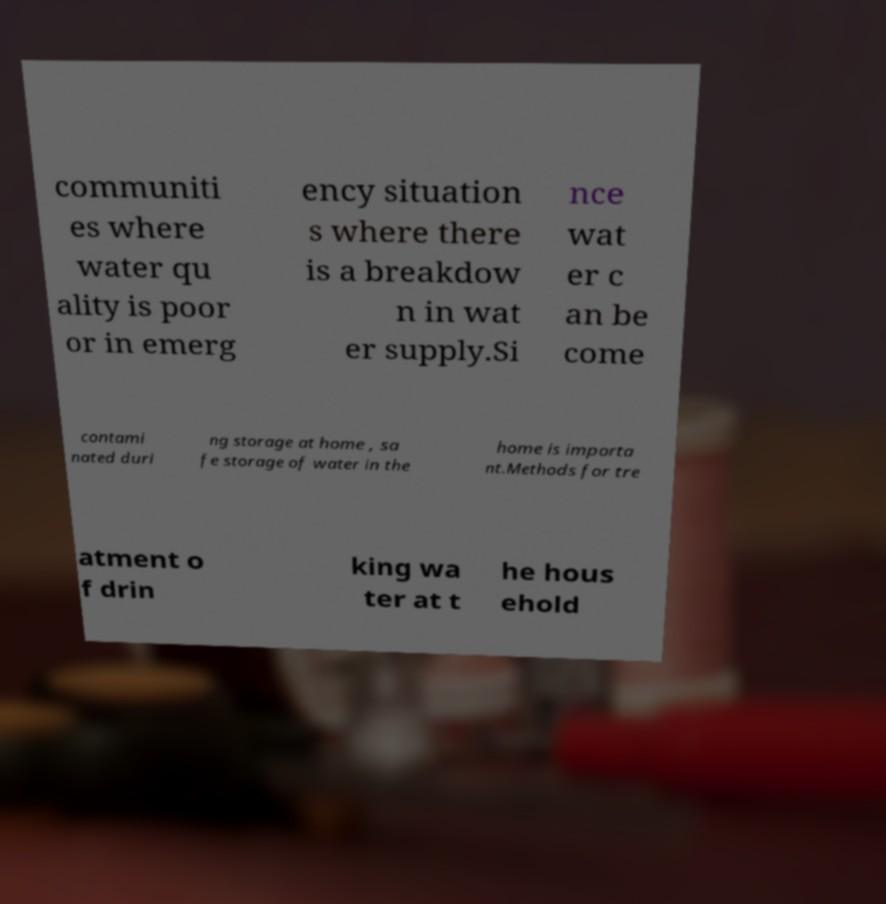Please identify and transcribe the text found in this image. communiti es where water qu ality is poor or in emerg ency situation s where there is a breakdow n in wat er supply.Si nce wat er c an be come contami nated duri ng storage at home , sa fe storage of water in the home is importa nt.Methods for tre atment o f drin king wa ter at t he hous ehold 